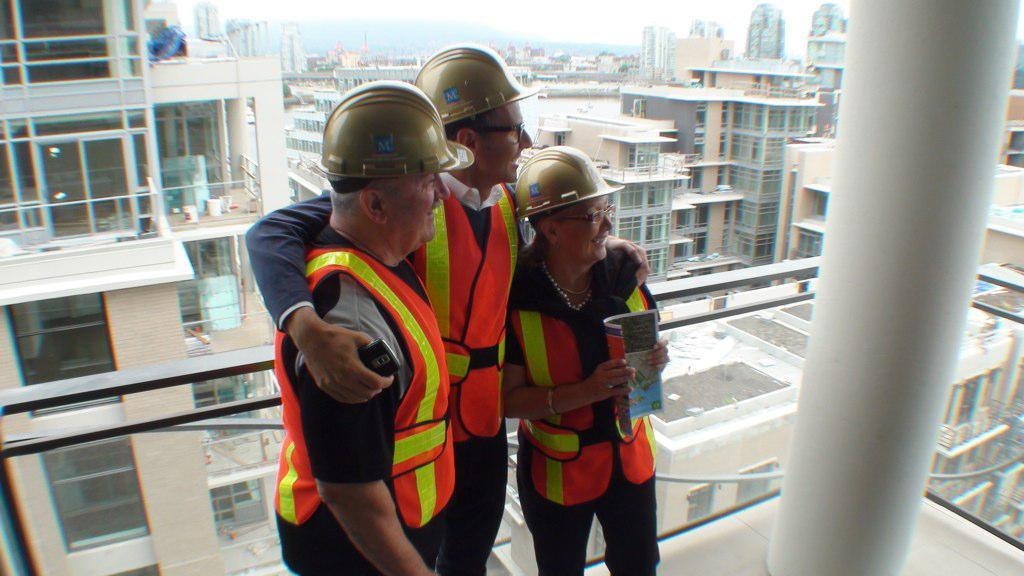How many people are present in the image? There are three people standing in the image. What are the people wearing? The people are wearing jackets. What can be seen in the background of the image? Buildings, windows, glass fencing, and pillars are visible in the background. What grade did the people receive in the image? There is no indication of a grade or any academic context in the image. 